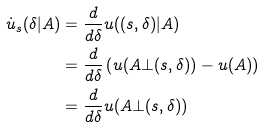<formula> <loc_0><loc_0><loc_500><loc_500>\dot { u } _ { s } ( \delta | A ) & = \frac { d } { d \delta } u ( ( s , \delta ) | A ) \\ & = \frac { d } { d \delta } \left ( u ( A \bot ( s , \delta ) ) - u ( A ) \right ) \\ & = \frac { d } { d \delta } u ( A \bot ( s , \delta ) )</formula> 